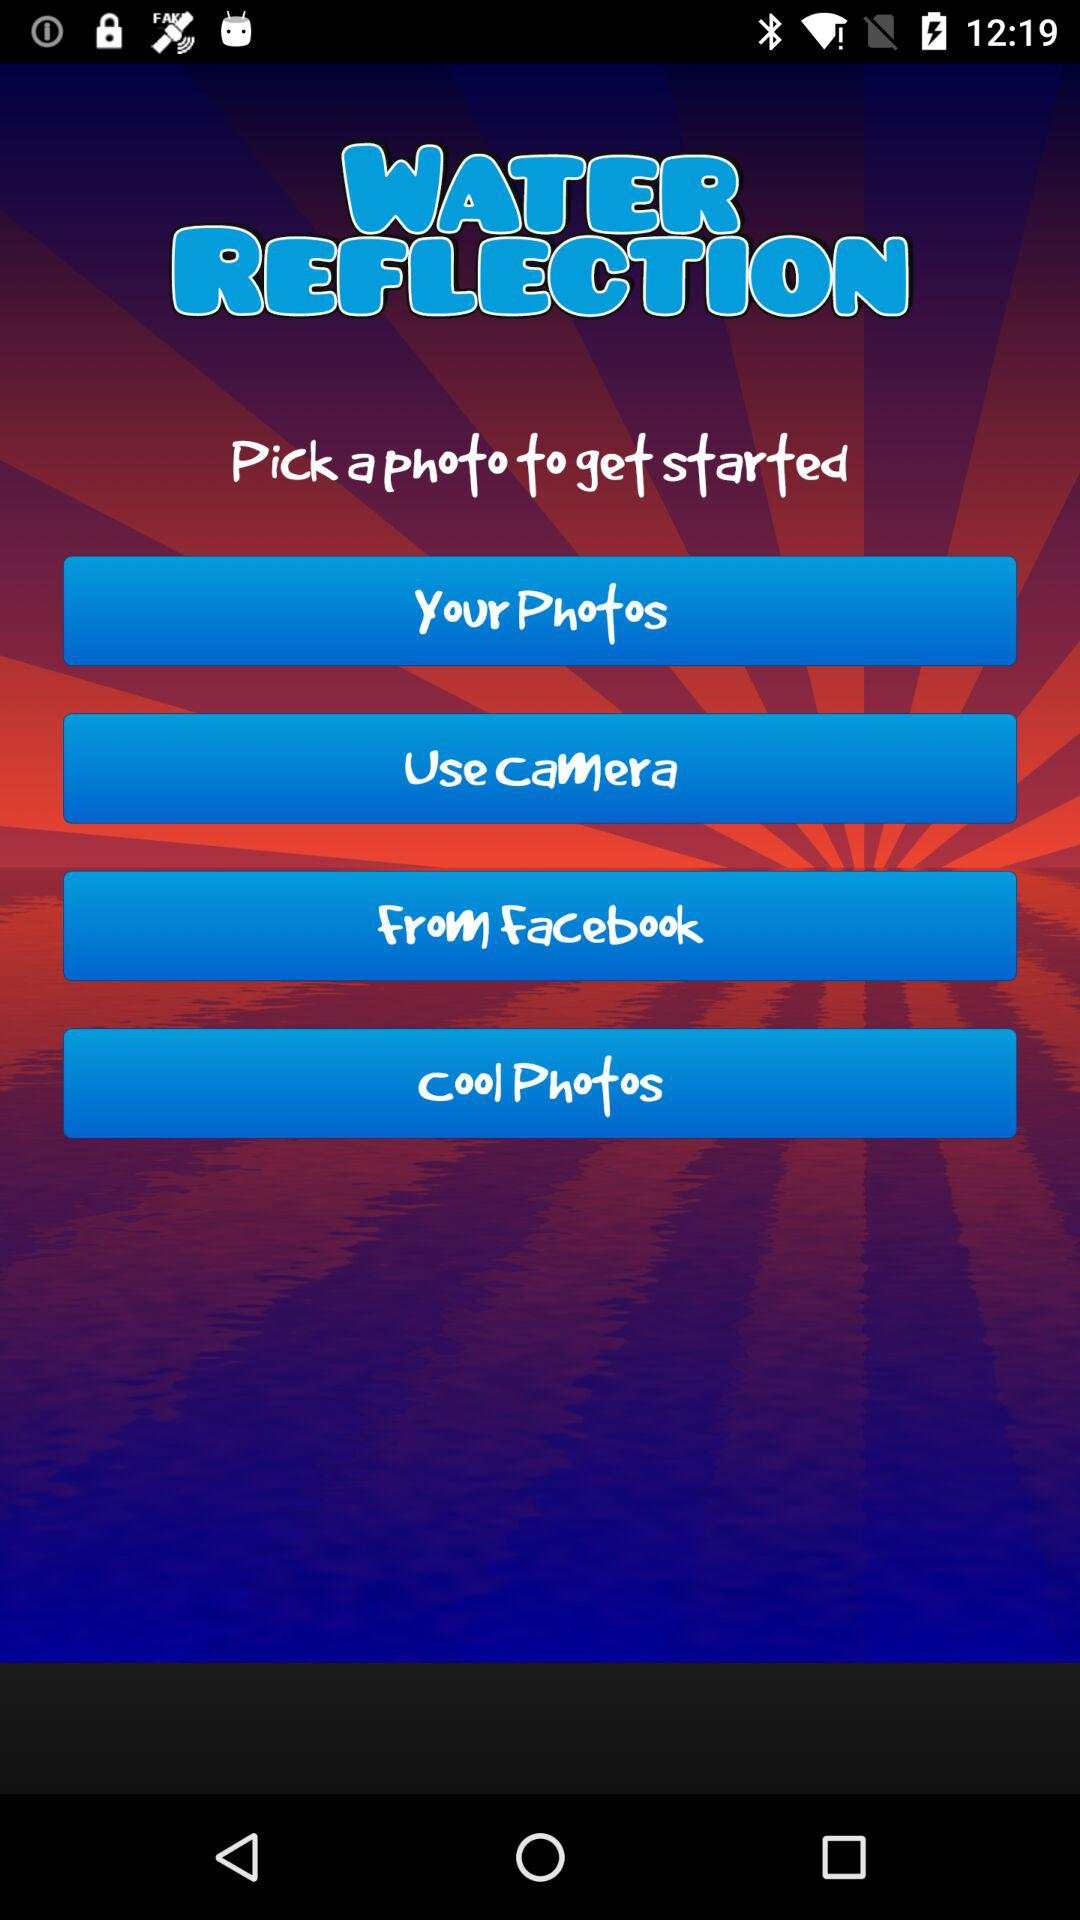What is the name of the application? The name of the application is "WATER REFLECTION". 